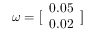Convert formula to latex. <formula><loc_0><loc_0><loc_500><loc_500>\omega = \left [ \begin{array} { l } { 0 . 0 5 } \\ { 0 . 0 2 } \end{array} \right ]</formula> 